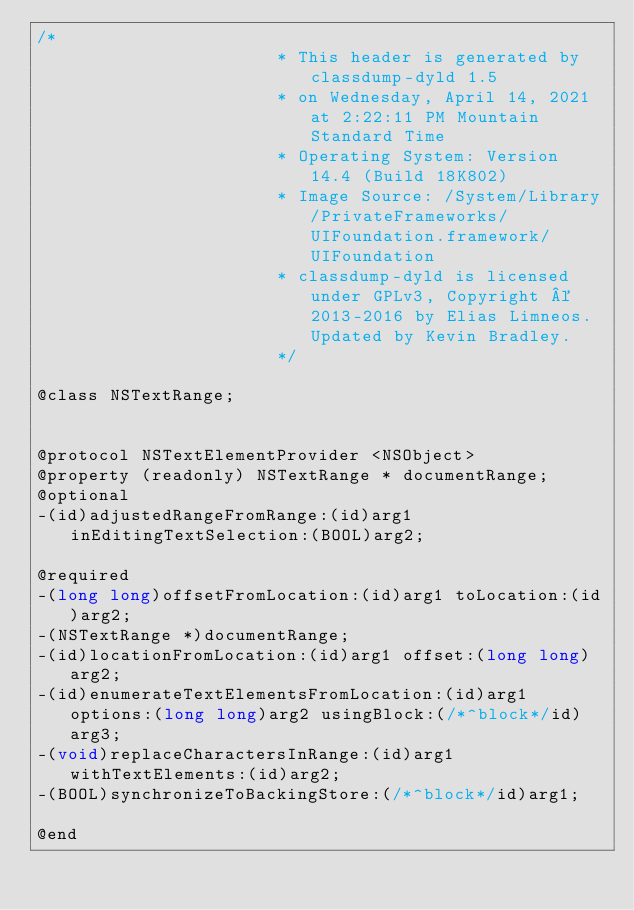Convert code to text. <code><loc_0><loc_0><loc_500><loc_500><_C_>/*
                       * This header is generated by classdump-dyld 1.5
                       * on Wednesday, April 14, 2021 at 2:22:11 PM Mountain Standard Time
                       * Operating System: Version 14.4 (Build 18K802)
                       * Image Source: /System/Library/PrivateFrameworks/UIFoundation.framework/UIFoundation
                       * classdump-dyld is licensed under GPLv3, Copyright © 2013-2016 by Elias Limneos. Updated by Kevin Bradley.
                       */

@class NSTextRange;


@protocol NSTextElementProvider <NSObject>
@property (readonly) NSTextRange * documentRange; 
@optional
-(id)adjustedRangeFromRange:(id)arg1 inEditingTextSelection:(BOOL)arg2;

@required
-(long long)offsetFromLocation:(id)arg1 toLocation:(id)arg2;
-(NSTextRange *)documentRange;
-(id)locationFromLocation:(id)arg1 offset:(long long)arg2;
-(id)enumerateTextElementsFromLocation:(id)arg1 options:(long long)arg2 usingBlock:(/*^block*/id)arg3;
-(void)replaceCharactersInRange:(id)arg1 withTextElements:(id)arg2;
-(BOOL)synchronizeToBackingStore:(/*^block*/id)arg1;

@end

</code> 